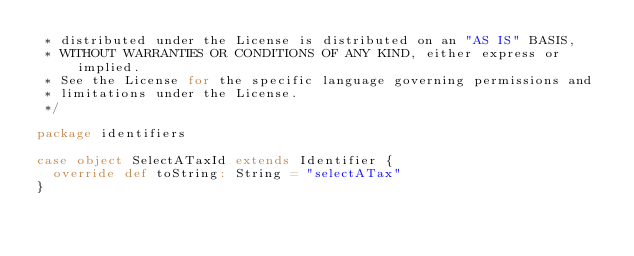Convert code to text. <code><loc_0><loc_0><loc_500><loc_500><_Scala_> * distributed under the License is distributed on an "AS IS" BASIS,
 * WITHOUT WARRANTIES OR CONDITIONS OF ANY KIND, either express or implied.
 * See the License for the specific language governing permissions and
 * limitations under the License.
 */

package identifiers

case object SelectATaxId extends Identifier {
  override def toString: String = "selectATax"
}
</code> 